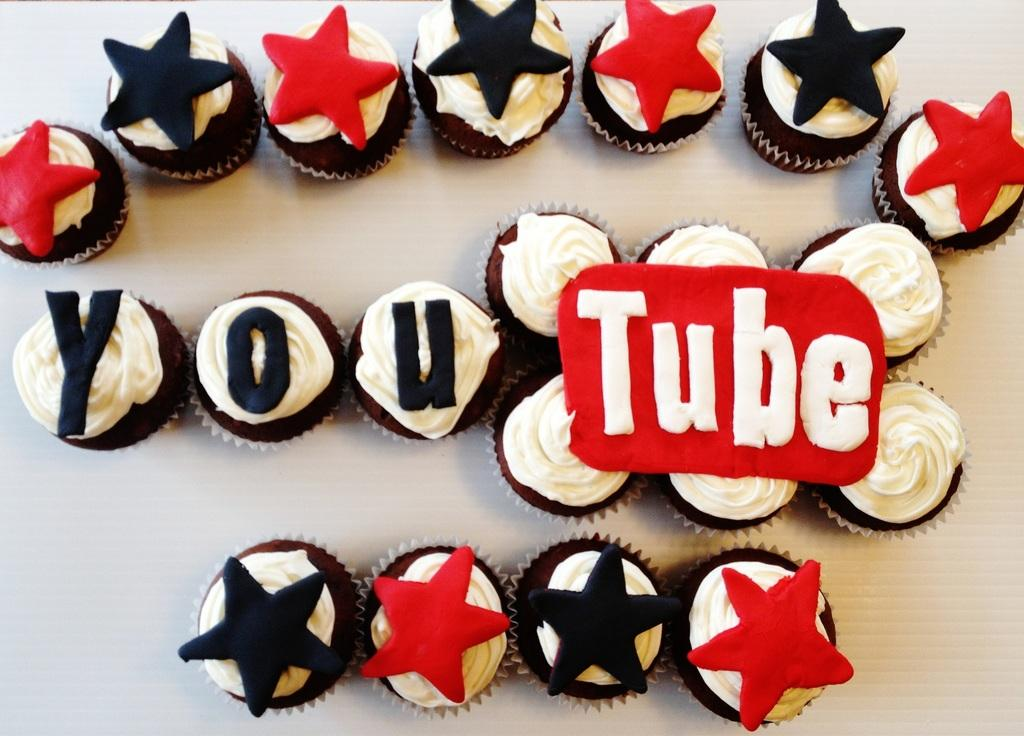What type of objects can be seen in the image? There are food items in the image. How are the food items arranged? The food items are arranged in a specific order. Is there any text present in the image? Yes, there is text written on the right side of the image. Can you see any feathers on the food items in the image? There are no feathers present on the food items in the image. How does the parcel play a role in the image? There is no parcel mentioned or depicted in the image. 